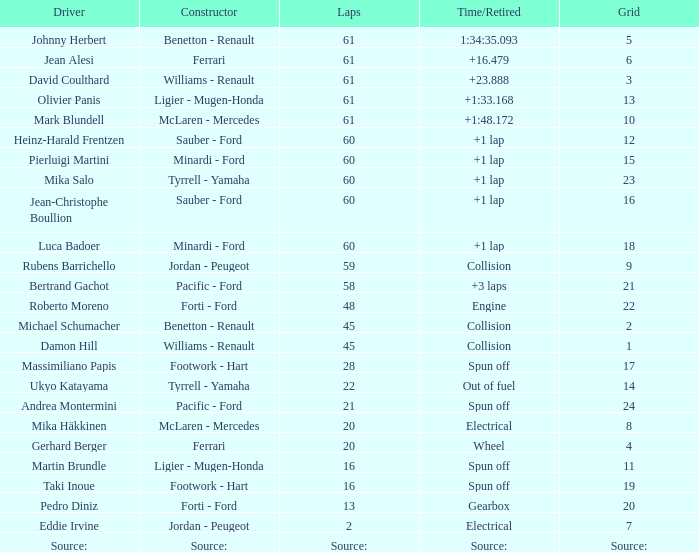With a time/retired of +1 lap, what is the count of laps jean-christophe boullion has successfully completed? 60.0. 